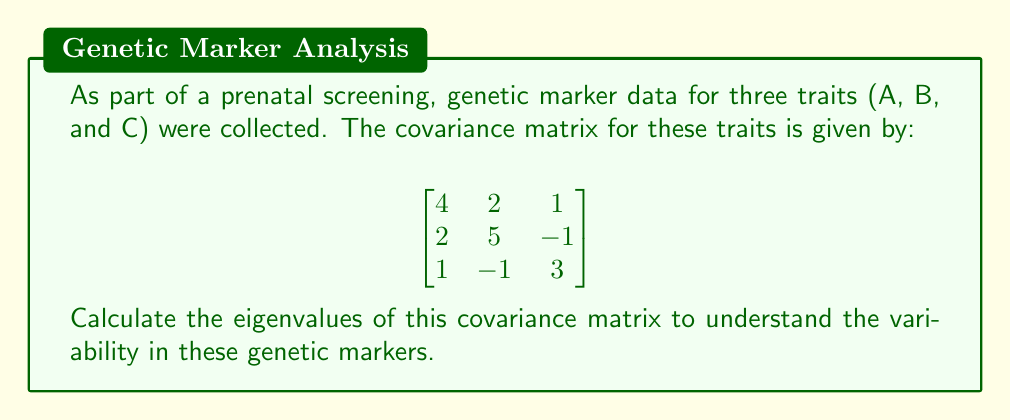Help me with this question. To find the eigenvalues of the covariance matrix, we need to solve the characteristic equation:

1) First, we set up the characteristic equation:
   $$det(A - \lambda I) = 0$$
   where $A$ is our covariance matrix and $I$ is the 3x3 identity matrix.

2) Expanding this, we get:
   $$
   \begin{vmatrix}
   4-\lambda & 2 & 1 \\
   2 & 5-\lambda & -1 \\
   1 & -1 & 3-\lambda
   \end{vmatrix} = 0
   $$

3) Calculating the determinant:
   $$(4-\lambda)[(5-\lambda)(3-\lambda)+1] - 2[2(3-\lambda)-1] + 1[2(-1)-(5-\lambda)] = 0$$

4) Simplifying:
   $$(4-\lambda)(15-8\lambda+\lambda^2+1) - 2(6-2\lambda-1) + (-2-5+\lambda) = 0$$
   $$(4-\lambda)(16-8\lambda+\lambda^2) - 2(5-2\lambda) + (-7+\lambda) = 0$$
   $$64-32\lambda+4\lambda^2-16\lambda+8\lambda^2-\lambda^3 - 10+4\lambda - 7+\lambda = 0$$

5) Collecting terms:
   $$-\lambda^3 + 12\lambda^2 - 43\lambda + 47 = 0$$

6) This cubic equation can be solved using various methods. Using a computer algebra system or factoring, we find the roots are:

   $\lambda_1 = 7$
   $\lambda_2 = 3$
   $\lambda_3 = 2$

These eigenvalues represent the variances along the principal components of the genetic marker data.
Answer: $\lambda_1 = 7$, $\lambda_2 = 3$, $\lambda_3 = 2$ 